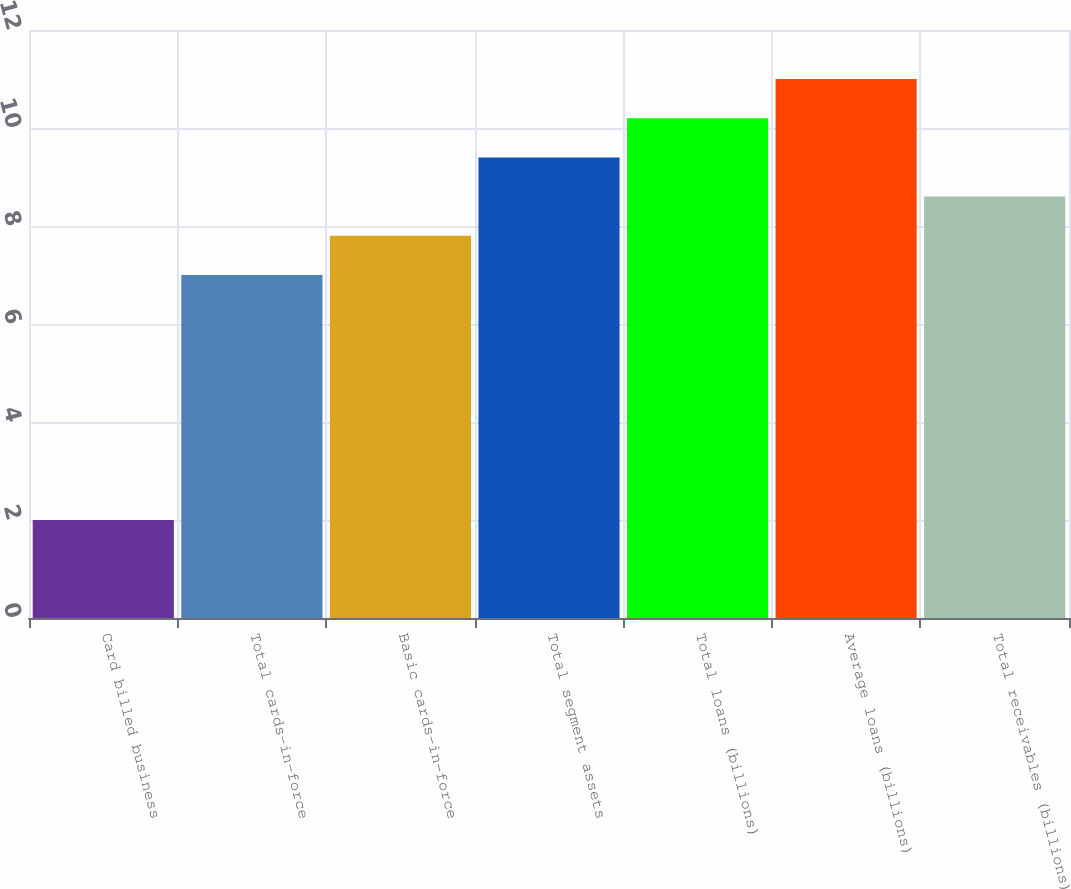<chart> <loc_0><loc_0><loc_500><loc_500><bar_chart><fcel>Card billed business<fcel>Total cards-in-force<fcel>Basic cards-in-force<fcel>Total segment assets<fcel>Total loans (billions)<fcel>Average loans (billions)<fcel>Total receivables (billions)<nl><fcel>2<fcel>7<fcel>7.8<fcel>9.4<fcel>10.2<fcel>11<fcel>8.6<nl></chart> 